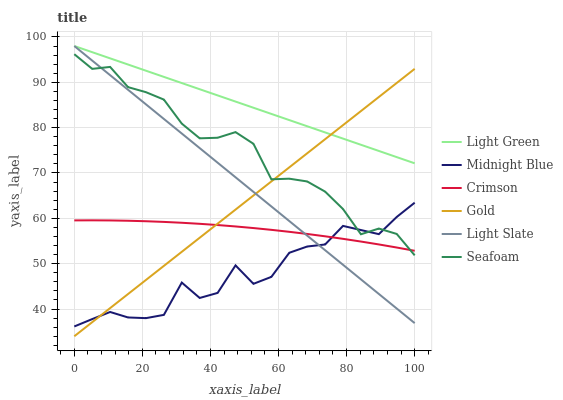Does Midnight Blue have the minimum area under the curve?
Answer yes or no. Yes. Does Light Green have the maximum area under the curve?
Answer yes or no. Yes. Does Gold have the minimum area under the curve?
Answer yes or no. No. Does Gold have the maximum area under the curve?
Answer yes or no. No. Is Light Slate the smoothest?
Answer yes or no. Yes. Is Midnight Blue the roughest?
Answer yes or no. Yes. Is Gold the smoothest?
Answer yes or no. No. Is Gold the roughest?
Answer yes or no. No. Does Gold have the lowest value?
Answer yes or no. Yes. Does Light Slate have the lowest value?
Answer yes or no. No. Does Light Green have the highest value?
Answer yes or no. Yes. Does Gold have the highest value?
Answer yes or no. No. Is Crimson less than Light Green?
Answer yes or no. Yes. Is Light Green greater than Crimson?
Answer yes or no. Yes. Does Light Green intersect Light Slate?
Answer yes or no. Yes. Is Light Green less than Light Slate?
Answer yes or no. No. Is Light Green greater than Light Slate?
Answer yes or no. No. Does Crimson intersect Light Green?
Answer yes or no. No. 